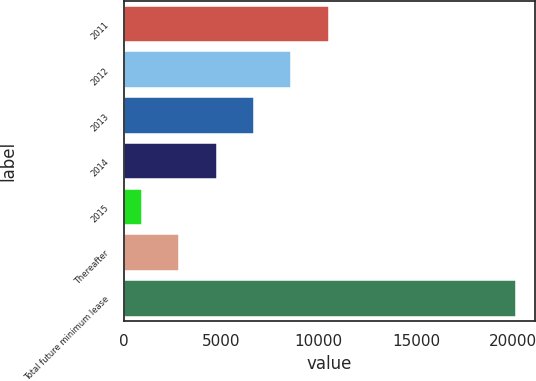Convert chart. <chart><loc_0><loc_0><loc_500><loc_500><bar_chart><fcel>2011<fcel>2012<fcel>2013<fcel>2014<fcel>2015<fcel>Thereafter<fcel>Total future minimum lease<nl><fcel>10530.5<fcel>8610<fcel>6689.5<fcel>4769<fcel>928<fcel>2848.5<fcel>20133<nl></chart> 